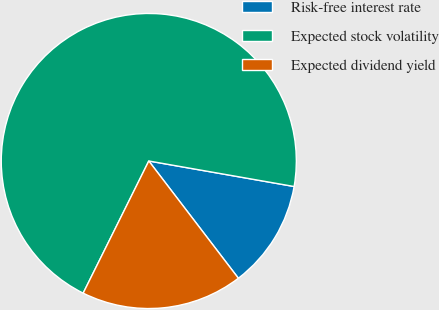Convert chart to OTSL. <chart><loc_0><loc_0><loc_500><loc_500><pie_chart><fcel>Risk-free interest rate<fcel>Expected stock volatility<fcel>Expected dividend yield<nl><fcel>11.85%<fcel>70.43%<fcel>17.72%<nl></chart> 